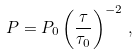Convert formula to latex. <formula><loc_0><loc_0><loc_500><loc_500>P = P _ { 0 } \left ( \frac { \tau } { \tau _ { 0 } } \right ) ^ { - 2 } \, ,</formula> 